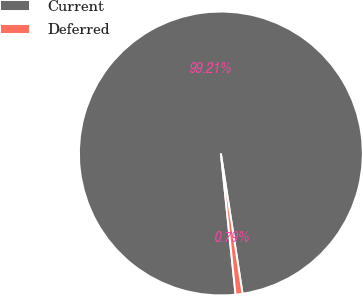Convert chart. <chart><loc_0><loc_0><loc_500><loc_500><pie_chart><fcel>Current<fcel>Deferred<nl><fcel>99.21%<fcel>0.79%<nl></chart> 